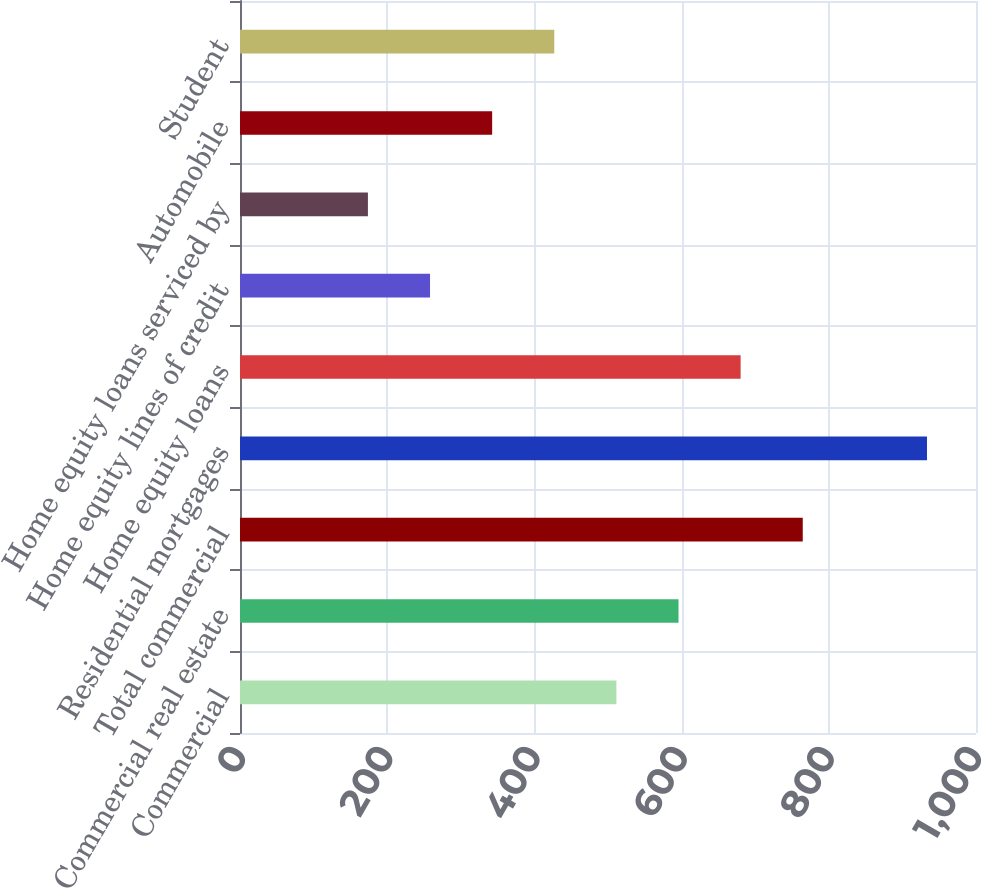<chart> <loc_0><loc_0><loc_500><loc_500><bar_chart><fcel>Commercial<fcel>Commercial real estate<fcel>Total commercial<fcel>Residential mortgages<fcel>Home equity loans<fcel>Home equity lines of credit<fcel>Home equity loans serviced by<fcel>Automobile<fcel>Student<nl><fcel>511.4<fcel>595.8<fcel>764.6<fcel>933.4<fcel>680.2<fcel>258.2<fcel>173.8<fcel>342.6<fcel>427<nl></chart> 